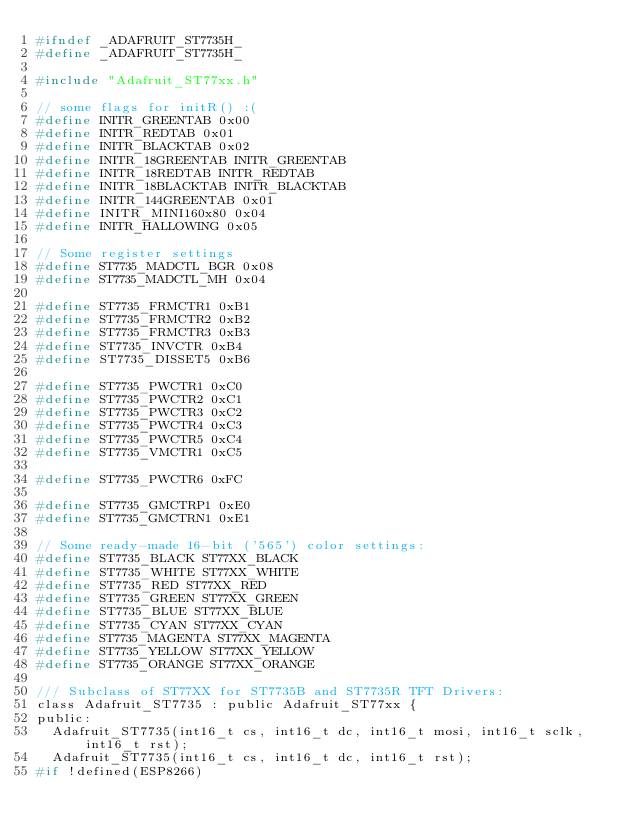Convert code to text. <code><loc_0><loc_0><loc_500><loc_500><_C_>#ifndef _ADAFRUIT_ST7735H_
#define _ADAFRUIT_ST7735H_

#include "Adafruit_ST77xx.h"

// some flags for initR() :(
#define INITR_GREENTAB 0x00
#define INITR_REDTAB 0x01
#define INITR_BLACKTAB 0x02
#define INITR_18GREENTAB INITR_GREENTAB
#define INITR_18REDTAB INITR_REDTAB
#define INITR_18BLACKTAB INITR_BLACKTAB
#define INITR_144GREENTAB 0x01
#define INITR_MINI160x80 0x04
#define INITR_HALLOWING 0x05

// Some register settings
#define ST7735_MADCTL_BGR 0x08
#define ST7735_MADCTL_MH 0x04

#define ST7735_FRMCTR1 0xB1
#define ST7735_FRMCTR2 0xB2
#define ST7735_FRMCTR3 0xB3
#define ST7735_INVCTR 0xB4
#define ST7735_DISSET5 0xB6

#define ST7735_PWCTR1 0xC0
#define ST7735_PWCTR2 0xC1
#define ST7735_PWCTR3 0xC2
#define ST7735_PWCTR4 0xC3
#define ST7735_PWCTR5 0xC4
#define ST7735_VMCTR1 0xC5

#define ST7735_PWCTR6 0xFC

#define ST7735_GMCTRP1 0xE0
#define ST7735_GMCTRN1 0xE1

// Some ready-made 16-bit ('565') color settings:
#define ST7735_BLACK ST77XX_BLACK
#define ST7735_WHITE ST77XX_WHITE
#define ST7735_RED ST77XX_RED
#define ST7735_GREEN ST77XX_GREEN
#define ST7735_BLUE ST77XX_BLUE
#define ST7735_CYAN ST77XX_CYAN
#define ST7735_MAGENTA ST77XX_MAGENTA
#define ST7735_YELLOW ST77XX_YELLOW
#define ST7735_ORANGE ST77XX_ORANGE

/// Subclass of ST77XX for ST7735B and ST7735R TFT Drivers:
class Adafruit_ST7735 : public Adafruit_ST77xx {
public:
  Adafruit_ST7735(int16_t cs, int16_t dc, int16_t mosi, int16_t sclk, int16_t rst);
  Adafruit_ST7735(int16_t cs, int16_t dc, int16_t rst);
#if !defined(ESP8266)</code> 